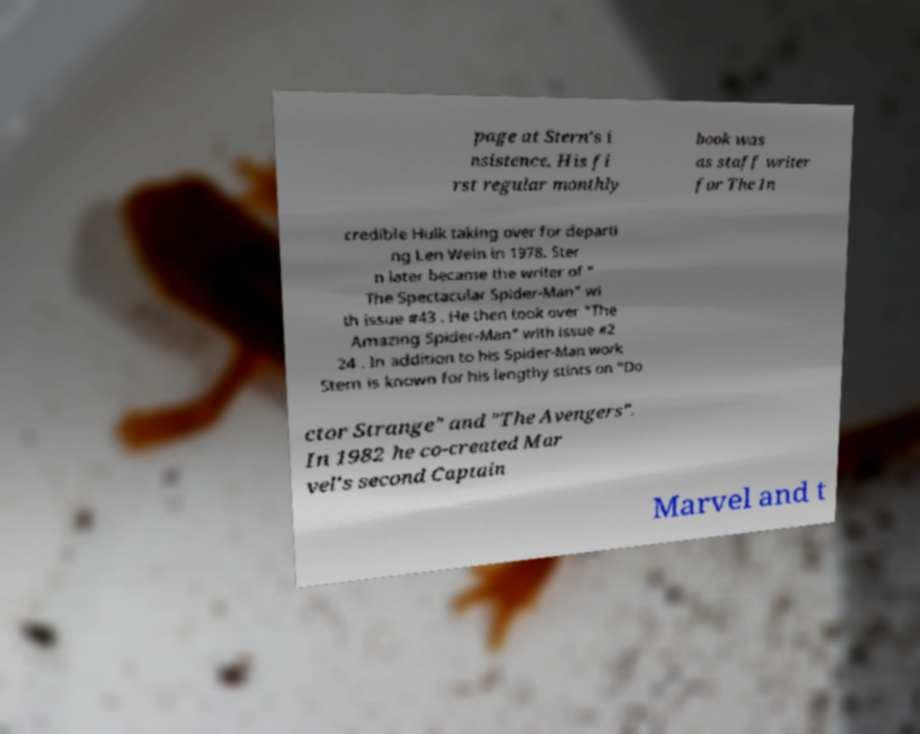Please identify and transcribe the text found in this image. page at Stern's i nsistence. His fi rst regular monthly book was as staff writer for The In credible Hulk taking over for departi ng Len Wein in 1978. Ster n later became the writer of " The Spectacular Spider-Man" wi th issue #43 . He then took over "The Amazing Spider-Man" with issue #2 24 . In addition to his Spider-Man work Stern is known for his lengthy stints on "Do ctor Strange" and "The Avengers". In 1982 he co-created Mar vel's second Captain Marvel and t 